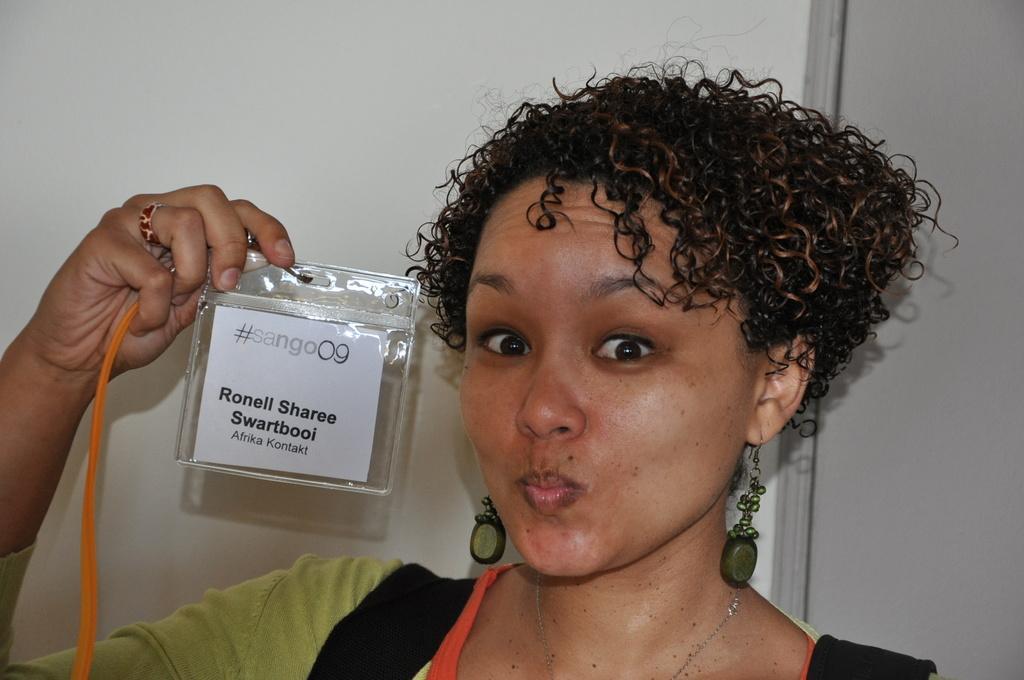In one or two sentences, can you explain what this image depicts? This image consists of a woman holding an ID card. She is wearing a green dress. In the background, there is a wall in white color. 